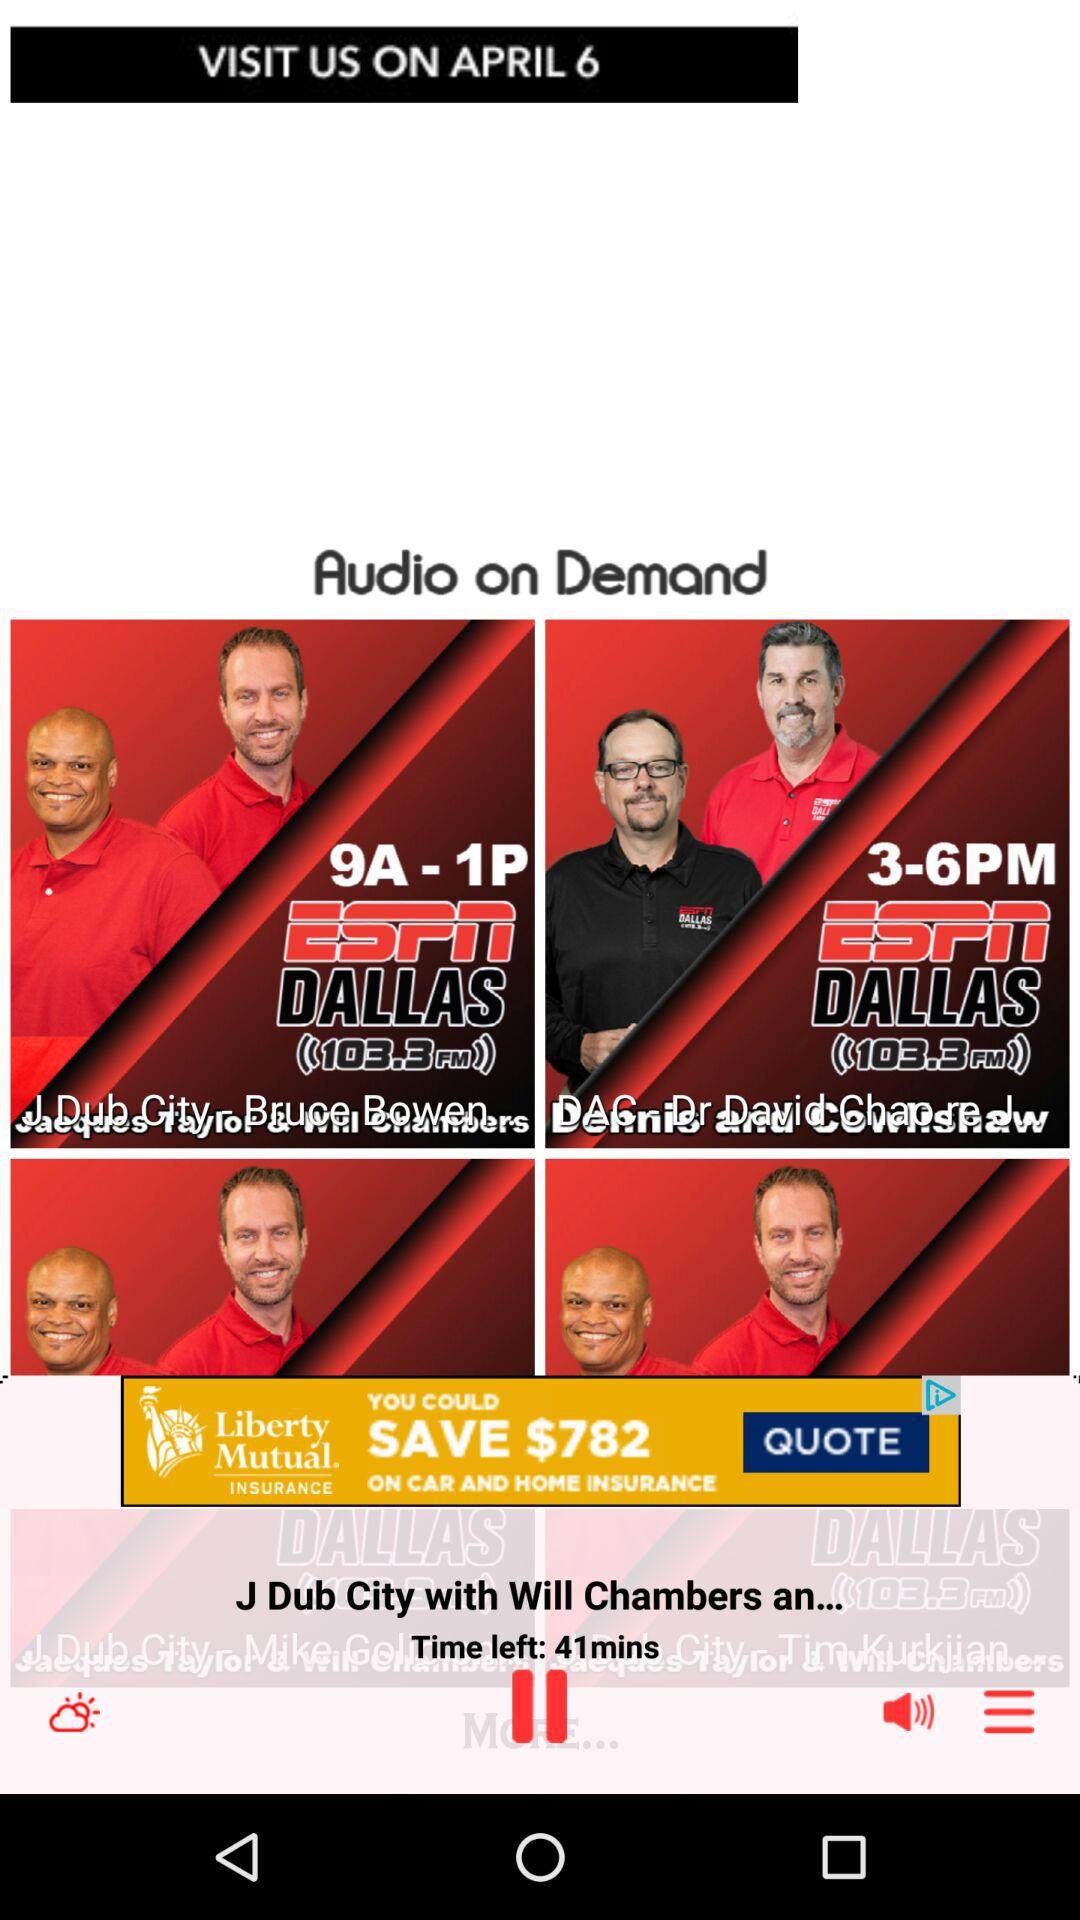On what date can we visit? You can visit on April 6. 